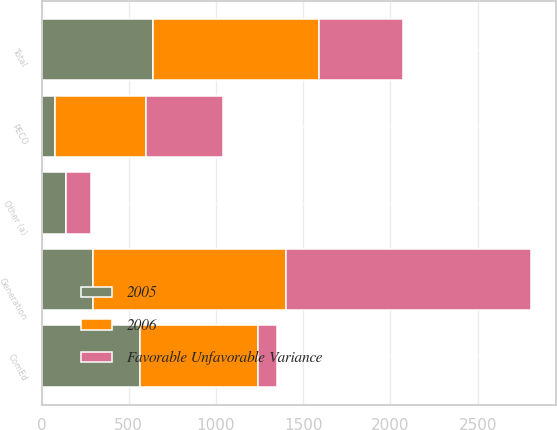Convert chart to OTSL. <chart><loc_0><loc_0><loc_500><loc_500><stacked_bar_chart><ecel><fcel>Generation<fcel>ComEd<fcel>PECO<fcel>Other (a)<fcel>Total<nl><fcel>Favorable Unfavorable Variance<fcel>1403<fcel>112<fcel>441<fcel>142<fcel>480.5<nl><fcel>2006<fcel>1109<fcel>676<fcel>520<fcel>2<fcel>951<nl><fcel>2005<fcel>294<fcel>564<fcel>79<fcel>140<fcel>639<nl></chart> 